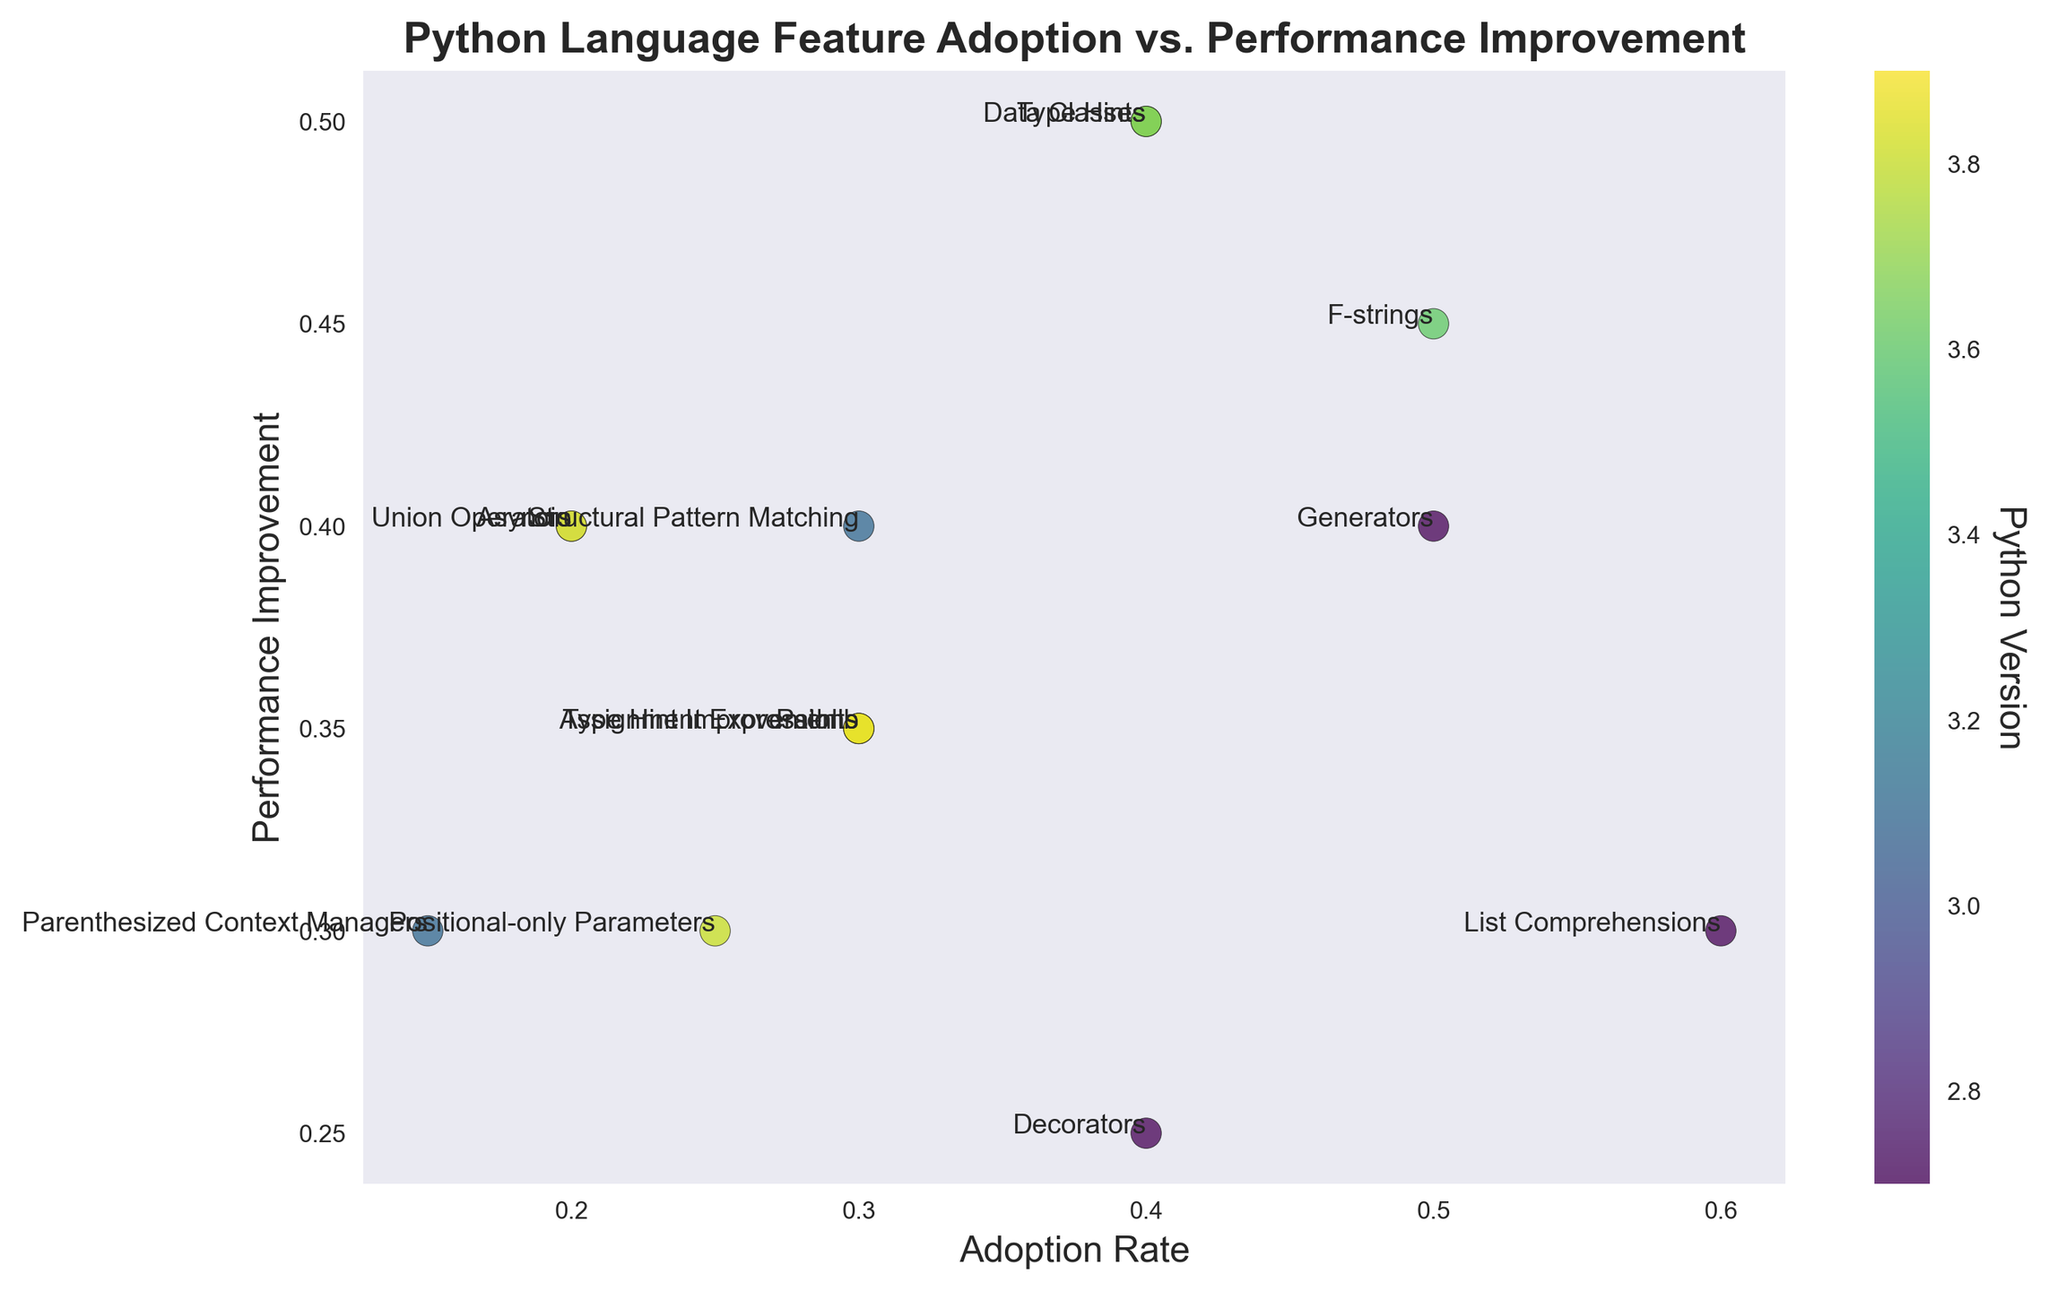What feature in Python 3.5 has the highest performance improvement? Look at the performance improvement axis for features introduced in Python 3.5. The highest point is Type Hints.
Answer: Type Hints Which feature has the lowest adoption rate in Python 3.10? Check the features introduced in Python 3.10 and compare their adoption rates. Parenthesized Context Managers has the lowest adoption rate of 0.15.
Answer: Parenthesized Context Managers What is the combined adoption rate of features introduced in Python 2.7? Sum the adoption rates of features in Python 2.7, which are List Comprehensions, Generators, and Decorators. The combined adoption rate is 0.6 + 0.5 + 0.4 = 1.5.
Answer: 1.5 Which version has the feature with the highest adoption rate? Compare the adoption rates of features in each version. List Comprehensions in version 2.7 has the highest rate of 0.6 among all features.
Answer: 2.7 What feature has the highest performance improvement regardless of adoption rate? Look at the performance improvement axis and identify the highest point, which corresponds to Type Hints in Python 3.5 with a value of 0.5.
Answer: Type Hints Which feature in Python 3.8 has the higher performance improvement? Compare the performance improvement values of features in Python 3.8. Assignment Expressions has a higher improvement of 0.35 compared to Positional-only Parameters with 0.3.
Answer: Assignment Expressions What is the average performance improvement of features in Python 3.9? Sum the performance improvements of features in Python 3.9 and divide by the number of features. (0.4 + 0.35) / 2 = 0.375
Answer: 0.375 Which feature has a higher adoption rate: Generators from Python 2.7 or Union Operators from Python 3.9? Compare the adoption rates of Generators (0.5) and Union Operators (0.2). Generators has a higher adoption rate.
Answer: Generators What is the highest adoption rate of features introduced in versions 3.6 and later? Examine the adoption rates of features introduced in versions 3.6 to 3.10. F-strings in version 3.6 has the highest rate of 0.5.
Answer: F-strings How does the performance improvement of Data Classes compare to Type Hint Improvements? Compare the performance improvements. Data Classes has an improvement of 0.5, while Type Hint Improvements has 0.35. Data Classes has a higher performance improvement.
Answer: Data Classes 